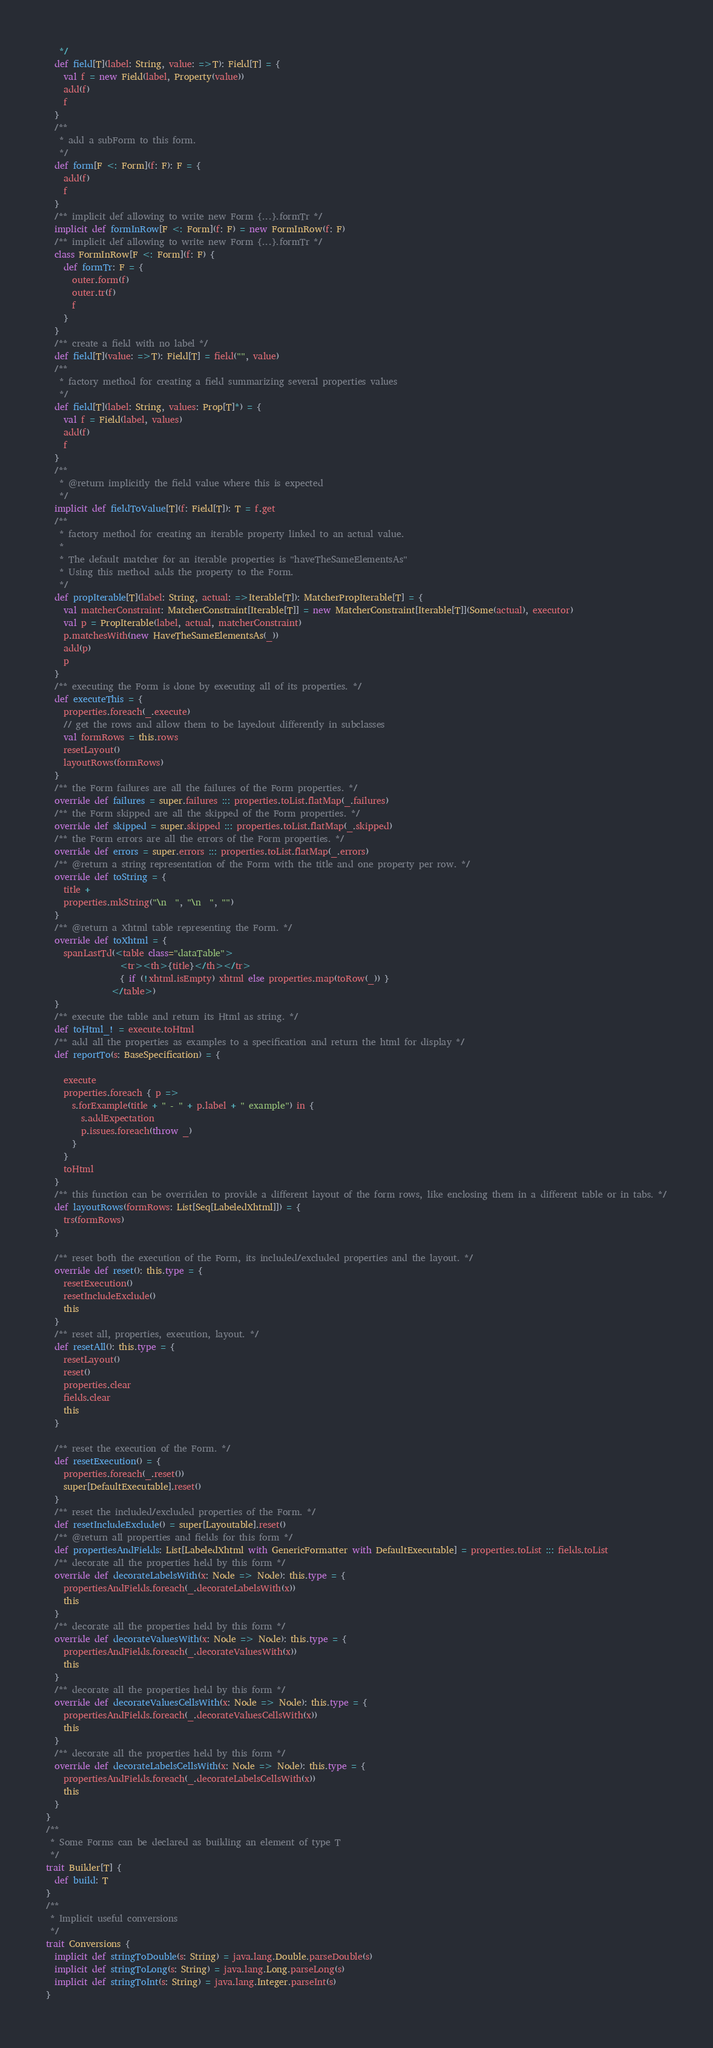Convert code to text. <code><loc_0><loc_0><loc_500><loc_500><_Scala_>   */
  def field[T](label: String, value: =>T): Field[T] = {
    val f = new Field(label, Property(value))
    add(f)
    f
  }
  /**
   * add a subForm to this form.
   */
  def form[F <: Form](f: F): F = {
    add(f)
    f
  }
  /** implicit def allowing to write new Form {...}.formTr */
  implicit def formInRow[F <: Form](f: F) = new FormInRow(f: F)
  /** implicit def allowing to write new Form {...}.formTr */
  class FormInRow[F <: Form](f: F) {
    def formTr: F = {
      outer.form(f)
      outer.tr(f)
      f
    }
  }
  /** create a field with no label */
  def field[T](value: =>T): Field[T] = field("", value)
  /**
   * factory method for creating a field summarizing several properties values
   */
  def field[T](label: String, values: Prop[T]*) = {
    val f = Field(label, values)
    add(f)
    f
  }
  /**
   * @return implicitly the field value where this is expected
   */
  implicit def fieldToValue[T](f: Field[T]): T = f.get
  /**
   * factory method for creating an iterable property linked to an actual value.
   *
   * The default matcher for an iterable properties is "haveTheSameElementsAs"
   * Using this method adds the property to the Form.
   */
  def propIterable[T](label: String, actual: =>Iterable[T]): MatcherPropIterable[T] = {
    val matcherConstraint: MatcherConstraint[Iterable[T]] = new MatcherConstraint[Iterable[T]](Some(actual), executor)
    val p = PropIterable(label, actual, matcherConstraint)
    p.matchesWith(new HaveTheSameElementsAs(_))
    add(p)
    p
  }
  /** executing the Form is done by executing all of its properties. */
  def executeThis = {
    properties.foreach(_.execute)
    // get the rows and allow them to be layedout differently in subclasses
    val formRows = this.rows 
    resetLayout()
    layoutRows(formRows)
  }
  /** the Form failures are all the failures of the Form properties. */
  override def failures = super.failures ::: properties.toList.flatMap(_.failures)
  /** the Form skipped are all the skipped of the Form properties. */
  override def skipped = super.skipped ::: properties.toList.flatMap(_.skipped)
  /** the Form errors are all the errors of the Form properties. */
  override def errors = super.errors ::: properties.toList.flatMap(_.errors)
  /** @return a string representation of the Form with the title and one property per row. */
  override def toString = {
    title +
    properties.mkString("\n  ", "\n  ", "")
  }
  /** @return a Xhtml table representing the Form. */
  override def toXhtml = {
    spanLastTd(<table class="dataTable">
                 <tr><th>{title}</th></tr>
                 { if (!xhtml.isEmpty) xhtml else properties.map(toRow(_)) }
               </table>)
  }
  /** execute the table and return its Html as string. */
  def toHtml_! = execute.toHtml
  /** add all the properties as examples to a specification and return the html for display */
  def reportTo(s: BaseSpecification) = {

    execute
    properties.foreach { p => 
      s.forExample(title + " - " + p.label + " example") in {
        s.addExpectation
        p.issues.foreach(throw _)
      }
    }
    toHtml
  }
  /** this function can be overriden to provide a different layout of the form rows, like enclosing them in a different table or in tabs. */
  def layoutRows(formRows: List[Seq[LabeledXhtml]]) = {
    trs(formRows)
  }

  /** reset both the execution of the Form, its included/excluded properties and the layout. */
  override def reset(): this.type = {
    resetExecution()
    resetIncludeExclude()
    this
  }
  /** reset all, properties, execution, layout. */
  def resetAll(): this.type = {
    resetLayout()
    reset()
    properties.clear
    fields.clear
    this
  }

  /** reset the execution of the Form. */
  def resetExecution() = {
    properties.foreach(_.reset())
    super[DefaultExecutable].reset()
  }
  /** reset the included/excluded properties of the Form. */
  def resetIncludeExclude() = super[Layoutable].reset()
  /** @return all properties and fields for this form */
  def propertiesAndFields: List[LabeledXhtml with GenericFormatter with DefaultExecutable] = properties.toList ::: fields.toList
  /** decorate all the properties held by this form */
  override def decorateLabelsWith(x: Node => Node): this.type = { 
    propertiesAndFields.foreach(_.decorateLabelsWith(x)) 
    this 
  }
  /** decorate all the properties held by this form */
  override def decorateValuesWith(x: Node => Node): this.type = {
    propertiesAndFields.foreach(_.decorateValuesWith(x)) 
    this 
  }
  /** decorate all the properties held by this form */
  override def decorateValuesCellsWith(x: Node => Node): this.type = { 
    propertiesAndFields.foreach(_.decorateValuesCellsWith(x)) 
    this
  }
  /** decorate all the properties held by this form */
  override def decorateLabelsCellsWith(x: Node => Node): this.type = { 
    propertiesAndFields.foreach(_.decorateLabelsCellsWith(x)) 
    this
  }
}
/**
 * Some Forms can be declared as building an element of type T
 */
trait Builder[T] {
  def build: T
}
/**
 * Implicit useful conversions
 */
trait Conversions {
  implicit def stringToDouble(s: String) = java.lang.Double.parseDouble(s)
  implicit def stringToLong(s: String) = java.lang.Long.parseLong(s)
  implicit def stringToInt(s: String) = java.lang.Integer.parseInt(s)
}
</code> 